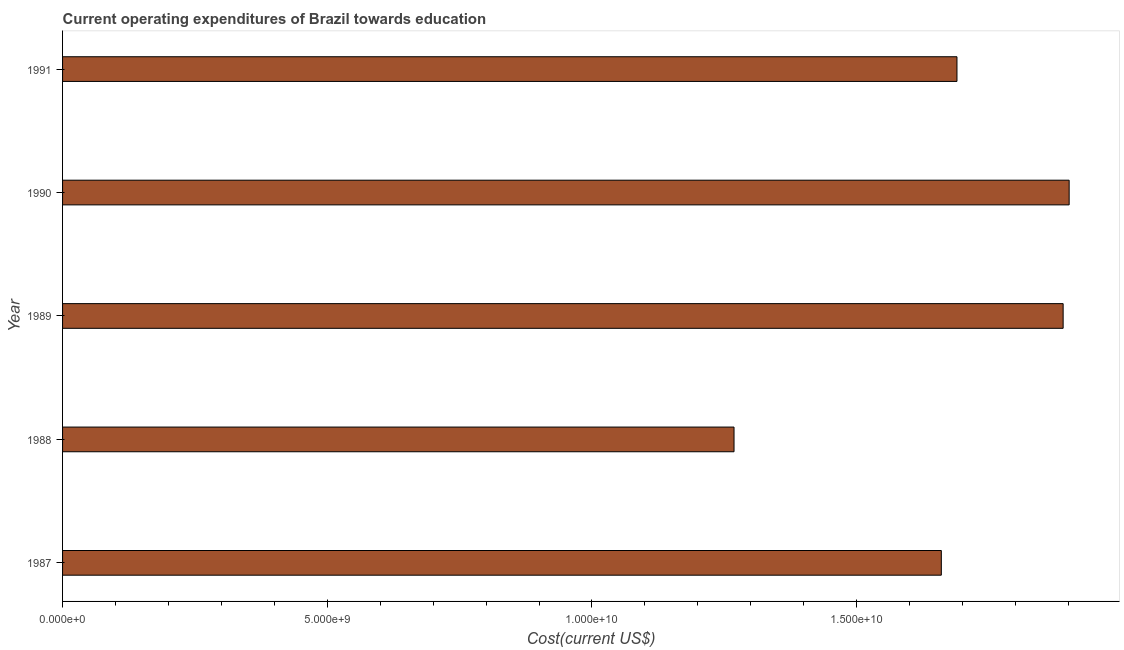Does the graph contain any zero values?
Your answer should be compact. No. Does the graph contain grids?
Your response must be concise. No. What is the title of the graph?
Your answer should be very brief. Current operating expenditures of Brazil towards education. What is the label or title of the X-axis?
Offer a terse response. Cost(current US$). What is the education expenditure in 1990?
Provide a short and direct response. 1.90e+1. Across all years, what is the maximum education expenditure?
Provide a succinct answer. 1.90e+1. Across all years, what is the minimum education expenditure?
Provide a short and direct response. 1.27e+1. In which year was the education expenditure maximum?
Your answer should be very brief. 1990. In which year was the education expenditure minimum?
Give a very brief answer. 1988. What is the sum of the education expenditure?
Offer a terse response. 8.41e+1. What is the difference between the education expenditure in 1989 and 1991?
Keep it short and to the point. 2.01e+09. What is the average education expenditure per year?
Provide a succinct answer. 1.68e+1. What is the median education expenditure?
Ensure brevity in your answer.  1.69e+1. In how many years, is the education expenditure greater than 14000000000 US$?
Make the answer very short. 4. What is the ratio of the education expenditure in 1988 to that in 1989?
Give a very brief answer. 0.67. What is the difference between the highest and the second highest education expenditure?
Give a very brief answer. 1.14e+08. Is the sum of the education expenditure in 1987 and 1989 greater than the maximum education expenditure across all years?
Ensure brevity in your answer.  Yes. What is the difference between the highest and the lowest education expenditure?
Your response must be concise. 6.33e+09. How many bars are there?
Provide a succinct answer. 5. What is the difference between two consecutive major ticks on the X-axis?
Make the answer very short. 5.00e+09. What is the Cost(current US$) of 1987?
Provide a short and direct response. 1.66e+1. What is the Cost(current US$) in 1988?
Provide a succinct answer. 1.27e+1. What is the Cost(current US$) in 1989?
Give a very brief answer. 1.89e+1. What is the Cost(current US$) of 1990?
Make the answer very short. 1.90e+1. What is the Cost(current US$) in 1991?
Make the answer very short. 1.69e+1. What is the difference between the Cost(current US$) in 1987 and 1988?
Keep it short and to the point. 3.92e+09. What is the difference between the Cost(current US$) in 1987 and 1989?
Keep it short and to the point. -2.30e+09. What is the difference between the Cost(current US$) in 1987 and 1990?
Provide a short and direct response. -2.41e+09. What is the difference between the Cost(current US$) in 1987 and 1991?
Provide a short and direct response. -2.95e+08. What is the difference between the Cost(current US$) in 1988 and 1989?
Ensure brevity in your answer.  -6.22e+09. What is the difference between the Cost(current US$) in 1988 and 1990?
Offer a terse response. -6.33e+09. What is the difference between the Cost(current US$) in 1988 and 1991?
Provide a short and direct response. -4.21e+09. What is the difference between the Cost(current US$) in 1989 and 1990?
Offer a very short reply. -1.14e+08. What is the difference between the Cost(current US$) in 1989 and 1991?
Your answer should be compact. 2.01e+09. What is the difference between the Cost(current US$) in 1990 and 1991?
Give a very brief answer. 2.12e+09. What is the ratio of the Cost(current US$) in 1987 to that in 1988?
Keep it short and to the point. 1.31. What is the ratio of the Cost(current US$) in 1987 to that in 1989?
Give a very brief answer. 0.88. What is the ratio of the Cost(current US$) in 1987 to that in 1990?
Provide a short and direct response. 0.87. What is the ratio of the Cost(current US$) in 1988 to that in 1989?
Give a very brief answer. 0.67. What is the ratio of the Cost(current US$) in 1988 to that in 1990?
Keep it short and to the point. 0.67. What is the ratio of the Cost(current US$) in 1988 to that in 1991?
Provide a short and direct response. 0.75. What is the ratio of the Cost(current US$) in 1989 to that in 1991?
Make the answer very short. 1.12. 